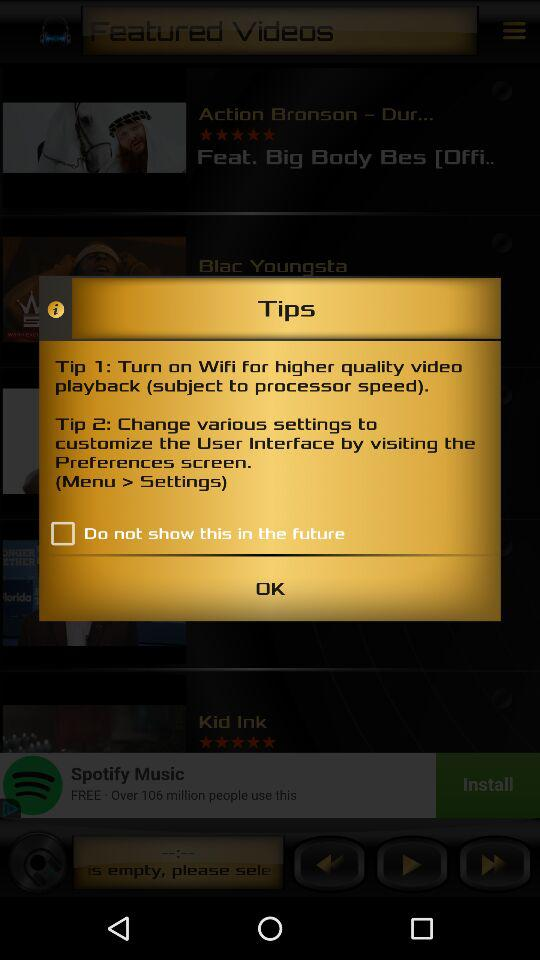How many tips are there?
Answer the question using a single word or phrase. 2 